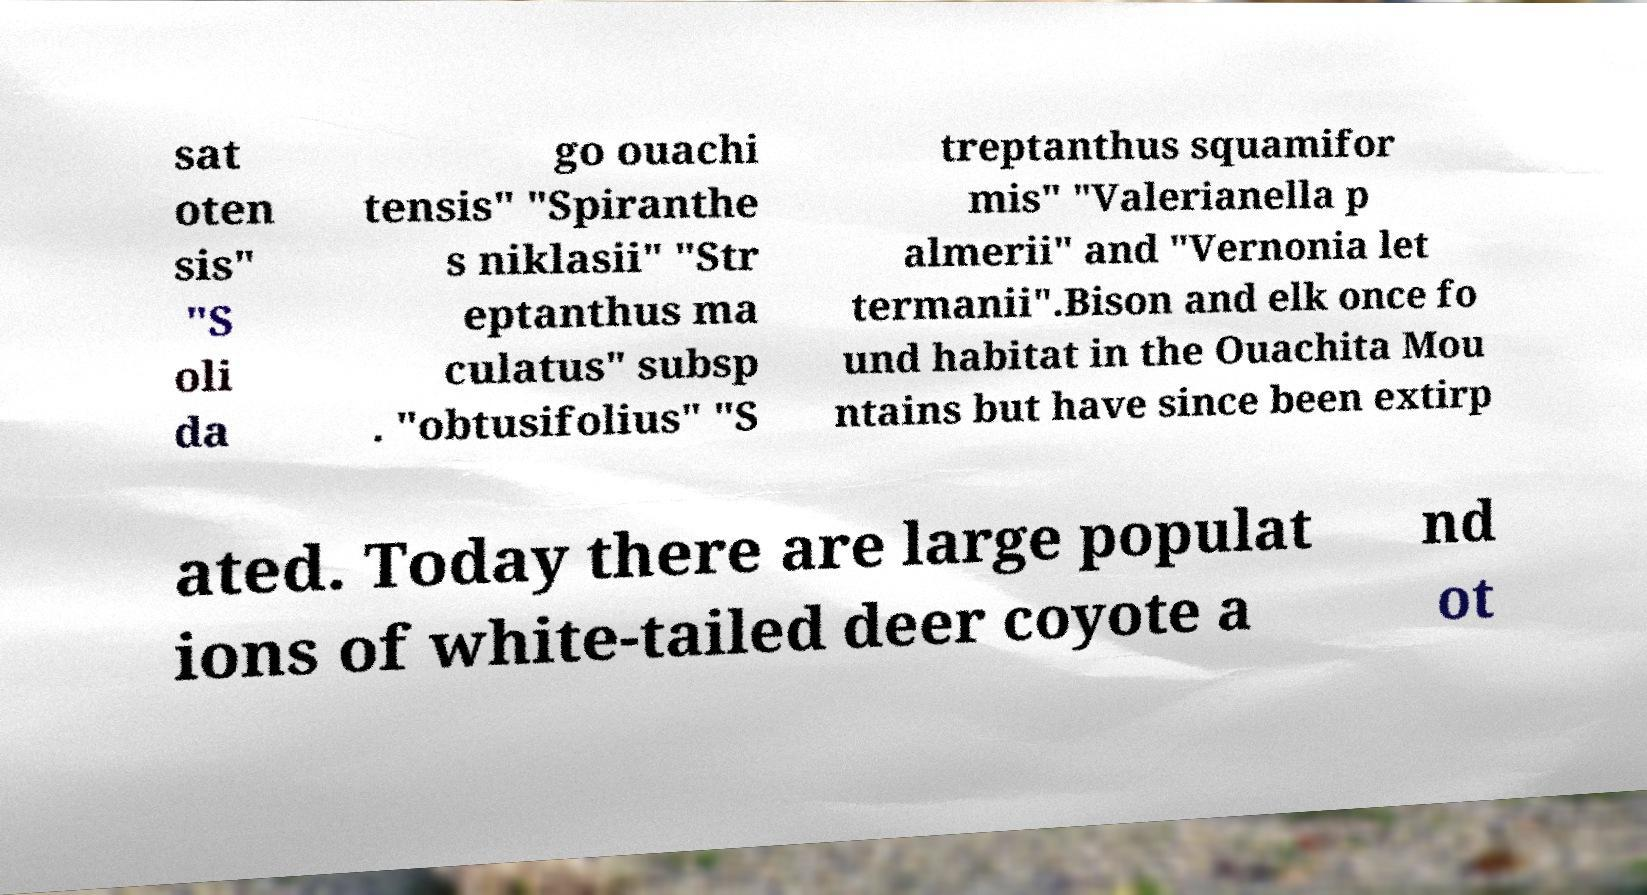There's text embedded in this image that I need extracted. Can you transcribe it verbatim? sat oten sis" "S oli da go ouachi tensis" "Spiranthe s niklasii" "Str eptanthus ma culatus" subsp . "obtusifolius" "S treptanthus squamifor mis" "Valerianella p almerii" and "Vernonia let termanii".Bison and elk once fo und habitat in the Ouachita Mou ntains but have since been extirp ated. Today there are large populat ions of white-tailed deer coyote a nd ot 